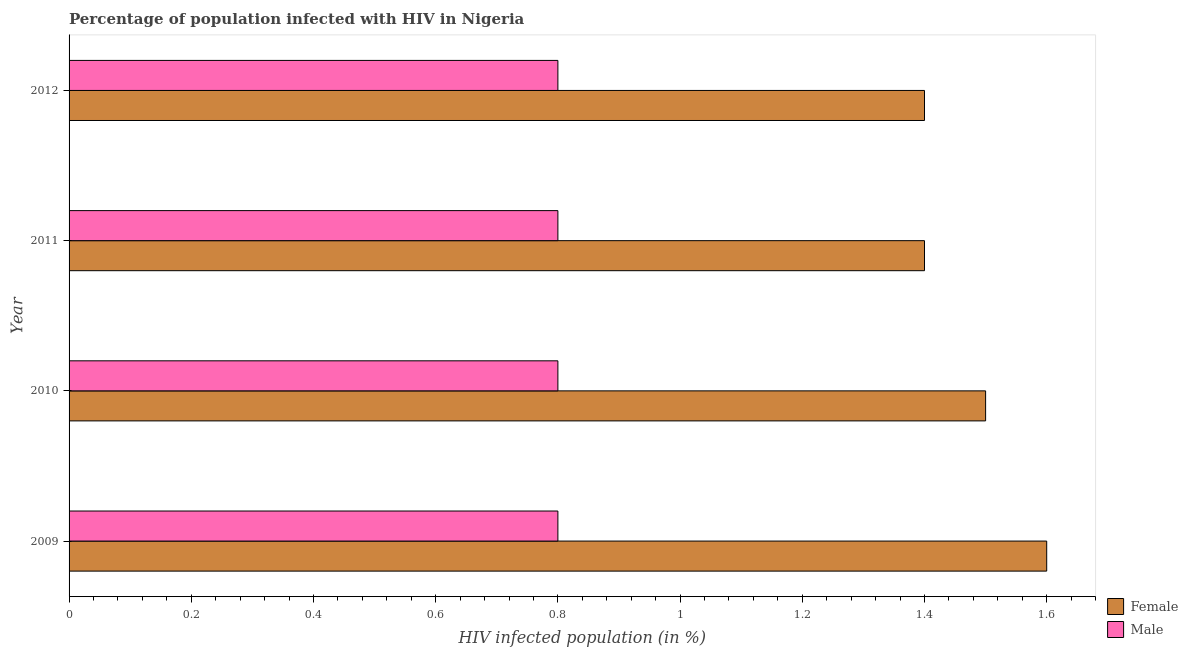How many bars are there on the 3rd tick from the top?
Your answer should be very brief. 2. How many bars are there on the 3rd tick from the bottom?
Offer a terse response. 2. What is the label of the 1st group of bars from the top?
Make the answer very short. 2012. What is the percentage of females who are infected with hiv in 2010?
Ensure brevity in your answer.  1.5. In which year was the percentage of females who are infected with hiv maximum?
Your answer should be very brief. 2009. What is the difference between the percentage of males who are infected with hiv in 2009 and that in 2011?
Ensure brevity in your answer.  0. What is the average percentage of females who are infected with hiv per year?
Keep it short and to the point. 1.48. In the year 2011, what is the difference between the percentage of males who are infected with hiv and percentage of females who are infected with hiv?
Provide a short and direct response. -0.6. What is the ratio of the percentage of females who are infected with hiv in 2009 to that in 2010?
Your response must be concise. 1.07. Is the difference between the percentage of females who are infected with hiv in 2011 and 2012 greater than the difference between the percentage of males who are infected with hiv in 2011 and 2012?
Give a very brief answer. No. In how many years, is the percentage of females who are infected with hiv greater than the average percentage of females who are infected with hiv taken over all years?
Keep it short and to the point. 2. What does the 2nd bar from the top in 2012 represents?
Keep it short and to the point. Female. What does the 2nd bar from the bottom in 2011 represents?
Make the answer very short. Male. Are all the bars in the graph horizontal?
Provide a succinct answer. Yes. How many years are there in the graph?
Keep it short and to the point. 4. What is the difference between two consecutive major ticks on the X-axis?
Ensure brevity in your answer.  0.2. Does the graph contain any zero values?
Offer a very short reply. No. Where does the legend appear in the graph?
Your answer should be compact. Bottom right. How many legend labels are there?
Provide a succinct answer. 2. What is the title of the graph?
Provide a succinct answer. Percentage of population infected with HIV in Nigeria. What is the label or title of the X-axis?
Give a very brief answer. HIV infected population (in %). What is the HIV infected population (in %) in Male in 2009?
Make the answer very short. 0.8. What is the HIV infected population (in %) in Male in 2010?
Ensure brevity in your answer.  0.8. What is the HIV infected population (in %) in Female in 2011?
Give a very brief answer. 1.4. What is the HIV infected population (in %) of Male in 2011?
Offer a terse response. 0.8. What is the HIV infected population (in %) in Female in 2012?
Ensure brevity in your answer.  1.4. Across all years, what is the maximum HIV infected population (in %) in Male?
Keep it short and to the point. 0.8. Across all years, what is the minimum HIV infected population (in %) of Female?
Ensure brevity in your answer.  1.4. What is the difference between the HIV infected population (in %) of Female in 2009 and that in 2011?
Provide a succinct answer. 0.2. What is the difference between the HIV infected population (in %) of Male in 2009 and that in 2011?
Provide a succinct answer. 0. What is the difference between the HIV infected population (in %) in Female in 2009 and that in 2012?
Your response must be concise. 0.2. What is the difference between the HIV infected population (in %) in Female in 2010 and that in 2012?
Your answer should be compact. 0.1. What is the difference between the HIV infected population (in %) in Male in 2011 and that in 2012?
Ensure brevity in your answer.  0. What is the difference between the HIV infected population (in %) in Female in 2009 and the HIV infected population (in %) in Male in 2010?
Offer a terse response. 0.8. What is the difference between the HIV infected population (in %) in Female in 2010 and the HIV infected population (in %) in Male in 2011?
Your answer should be compact. 0.7. What is the average HIV infected population (in %) in Female per year?
Offer a very short reply. 1.48. What is the average HIV infected population (in %) in Male per year?
Your answer should be very brief. 0.8. In the year 2010, what is the difference between the HIV infected population (in %) of Female and HIV infected population (in %) of Male?
Keep it short and to the point. 0.7. In the year 2011, what is the difference between the HIV infected population (in %) in Female and HIV infected population (in %) in Male?
Provide a short and direct response. 0.6. In the year 2012, what is the difference between the HIV infected population (in %) in Female and HIV infected population (in %) in Male?
Offer a very short reply. 0.6. What is the ratio of the HIV infected population (in %) of Female in 2009 to that in 2010?
Offer a terse response. 1.07. What is the ratio of the HIV infected population (in %) of Male in 2009 to that in 2010?
Your answer should be compact. 1. What is the ratio of the HIV infected population (in %) in Male in 2009 to that in 2012?
Offer a terse response. 1. What is the ratio of the HIV infected population (in %) of Female in 2010 to that in 2011?
Provide a short and direct response. 1.07. What is the ratio of the HIV infected population (in %) of Male in 2010 to that in 2011?
Keep it short and to the point. 1. What is the ratio of the HIV infected population (in %) in Female in 2010 to that in 2012?
Offer a very short reply. 1.07. What is the ratio of the HIV infected population (in %) of Male in 2011 to that in 2012?
Provide a short and direct response. 1. What is the difference between the highest and the second highest HIV infected population (in %) of Female?
Provide a short and direct response. 0.1. 